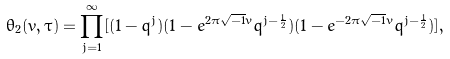Convert formula to latex. <formula><loc_0><loc_0><loc_500><loc_500>\theta _ { 2 } ( v , \tau ) = \prod _ { j = 1 } ^ { \infty } [ ( 1 - q ^ { j } ) ( 1 - e ^ { 2 \pi \sqrt { - 1 } v } q ^ { j - \frac { 1 } { 2 } } ) ( 1 - e ^ { - 2 \pi \sqrt { - 1 } v } q ^ { j - \frac { 1 } { 2 } } ) ] ,</formula> 